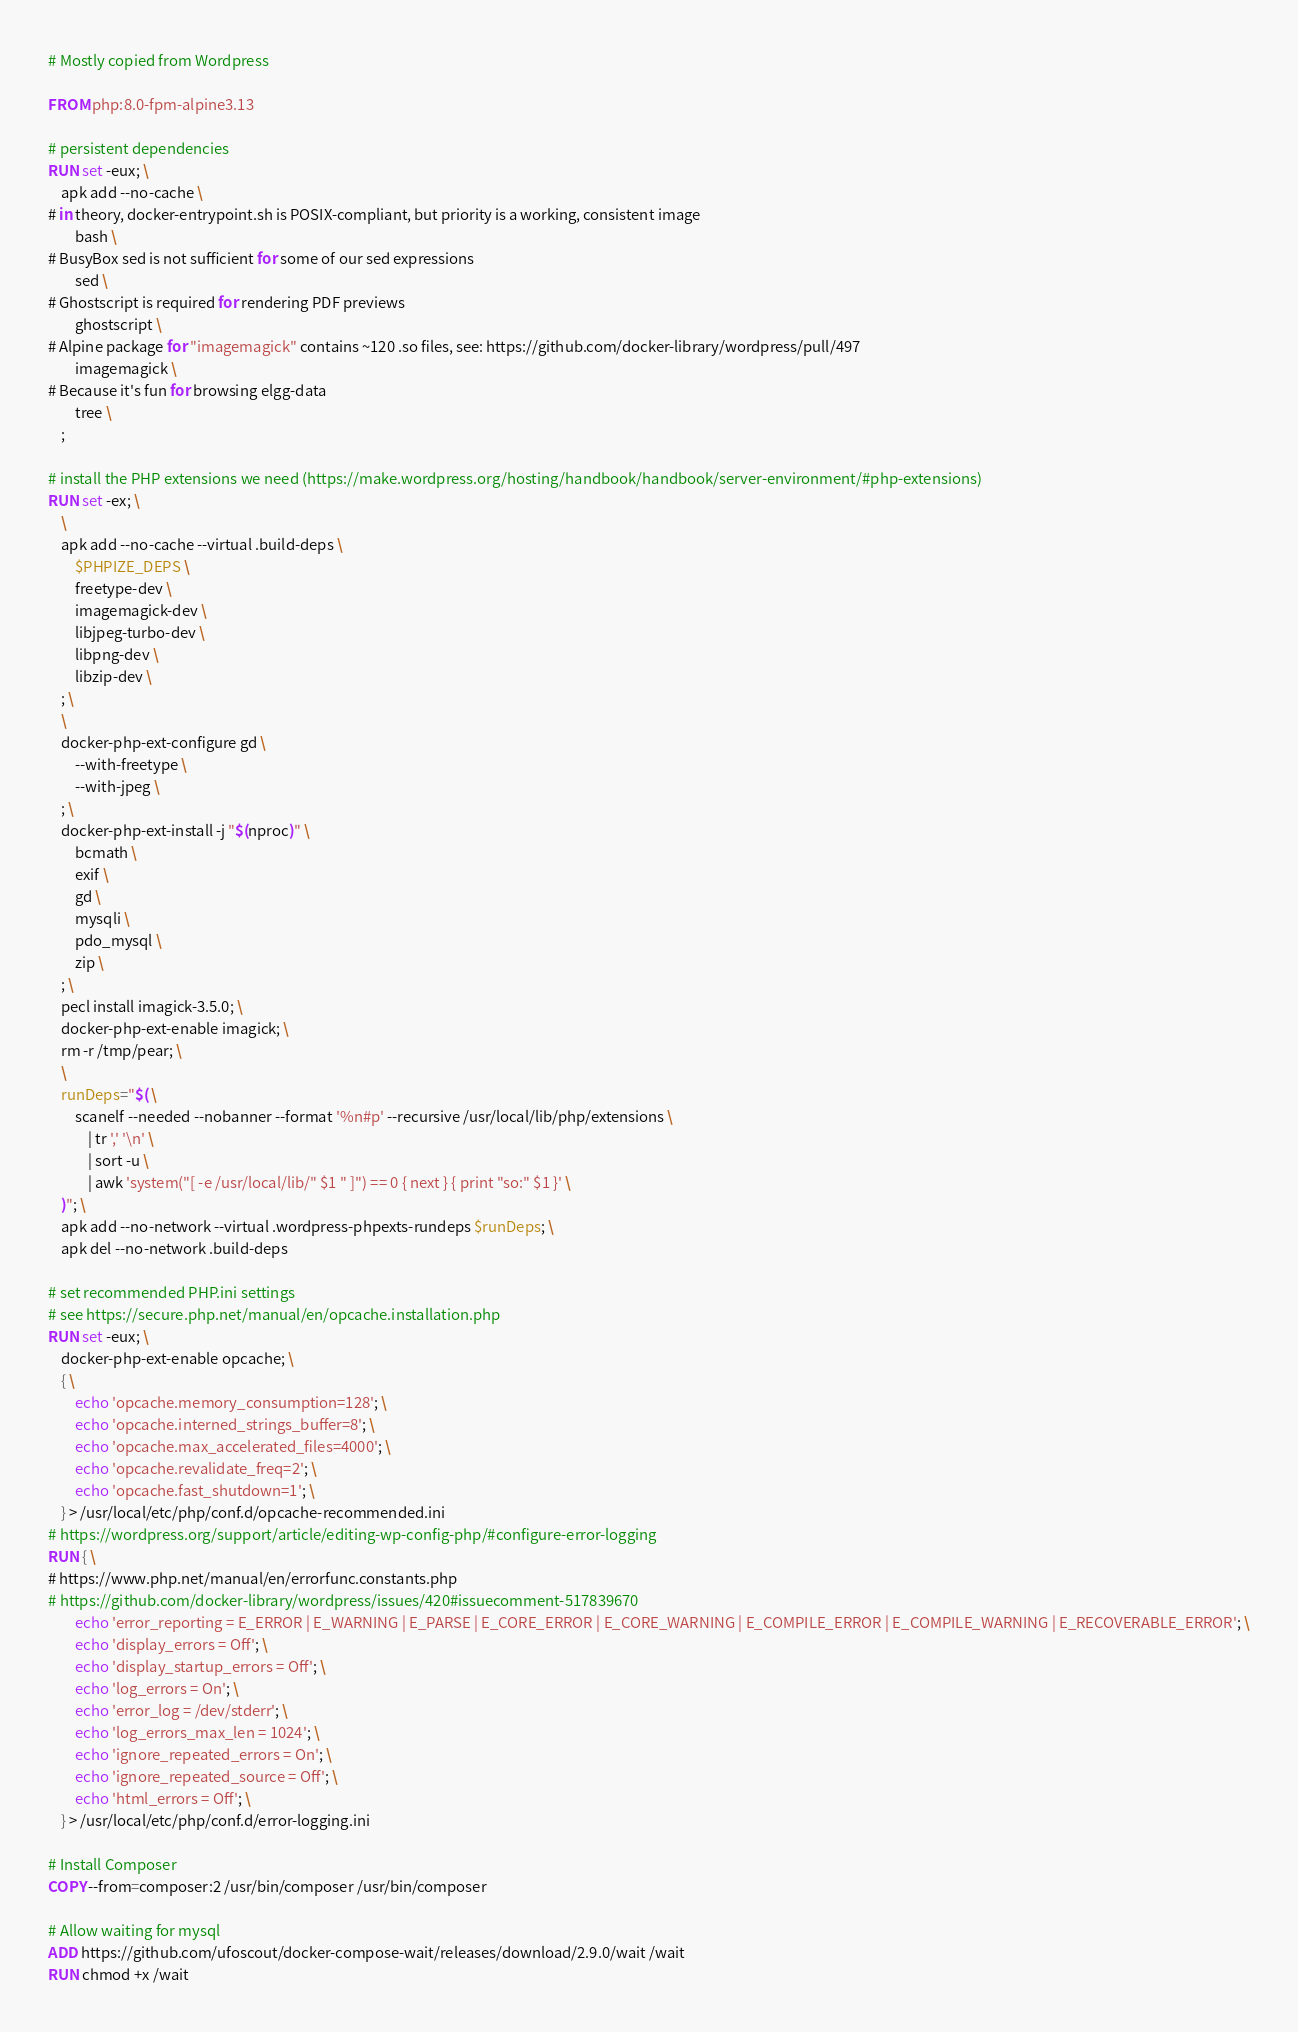Convert code to text. <code><loc_0><loc_0><loc_500><loc_500><_Dockerfile_># Mostly copied from Wordpress

FROM php:8.0-fpm-alpine3.13

# persistent dependencies
RUN set -eux; \
	apk add --no-cache \
# in theory, docker-entrypoint.sh is POSIX-compliant, but priority is a working, consistent image
		bash \
# BusyBox sed is not sufficient for some of our sed expressions
		sed \
# Ghostscript is required for rendering PDF previews
		ghostscript \
# Alpine package for "imagemagick" contains ~120 .so files, see: https://github.com/docker-library/wordpress/pull/497
		imagemagick \
# Because it's fun for browsing elgg-data
		tree \
	;

# install the PHP extensions we need (https://make.wordpress.org/hosting/handbook/handbook/server-environment/#php-extensions)
RUN set -ex; \
	\
	apk add --no-cache --virtual .build-deps \
		$PHPIZE_DEPS \
		freetype-dev \
		imagemagick-dev \
		libjpeg-turbo-dev \
		libpng-dev \
		libzip-dev \
	; \
	\
	docker-php-ext-configure gd \
		--with-freetype \
		--with-jpeg \
	; \
	docker-php-ext-install -j "$(nproc)" \
		bcmath \
		exif \
		gd \
		mysqli \
		pdo_mysql \
		zip \
	; \
	pecl install imagick-3.5.0; \
	docker-php-ext-enable imagick; \
	rm -r /tmp/pear; \
	\
	runDeps="$( \
		scanelf --needed --nobanner --format '%n#p' --recursive /usr/local/lib/php/extensions \
			| tr ',' '\n' \
			| sort -u \
			| awk 'system("[ -e /usr/local/lib/" $1 " ]") == 0 { next } { print "so:" $1 }' \
	)"; \
	apk add --no-network --virtual .wordpress-phpexts-rundeps $runDeps; \
	apk del --no-network .build-deps

# set recommended PHP.ini settings
# see https://secure.php.net/manual/en/opcache.installation.php
RUN set -eux; \
	docker-php-ext-enable opcache; \
	{ \
		echo 'opcache.memory_consumption=128'; \
		echo 'opcache.interned_strings_buffer=8'; \
		echo 'opcache.max_accelerated_files=4000'; \
		echo 'opcache.revalidate_freq=2'; \
		echo 'opcache.fast_shutdown=1'; \
	} > /usr/local/etc/php/conf.d/opcache-recommended.ini
# https://wordpress.org/support/article/editing-wp-config-php/#configure-error-logging
RUN { \
# https://www.php.net/manual/en/errorfunc.constants.php
# https://github.com/docker-library/wordpress/issues/420#issuecomment-517839670
		echo 'error_reporting = E_ERROR | E_WARNING | E_PARSE | E_CORE_ERROR | E_CORE_WARNING | E_COMPILE_ERROR | E_COMPILE_WARNING | E_RECOVERABLE_ERROR'; \
		echo 'display_errors = Off'; \
		echo 'display_startup_errors = Off'; \
		echo 'log_errors = On'; \
		echo 'error_log = /dev/stderr'; \
		echo 'log_errors_max_len = 1024'; \
		echo 'ignore_repeated_errors = On'; \
		echo 'ignore_repeated_source = Off'; \
		echo 'html_errors = Off'; \
	} > /usr/local/etc/php/conf.d/error-logging.ini

# Install Composer
COPY --from=composer:2 /usr/bin/composer /usr/bin/composer

# Allow waiting for mysql
ADD https://github.com/ufoscout/docker-compose-wait/releases/download/2.9.0/wait /wait
RUN chmod +x /wait
</code> 